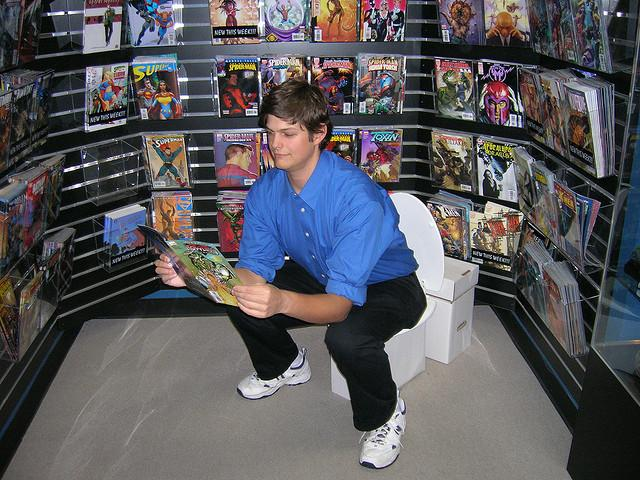What type of store is this? comic book 